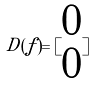Convert formula to latex. <formula><loc_0><loc_0><loc_500><loc_500>D ( f ) = [ \begin{matrix} 0 \\ 0 \end{matrix} ]</formula> 